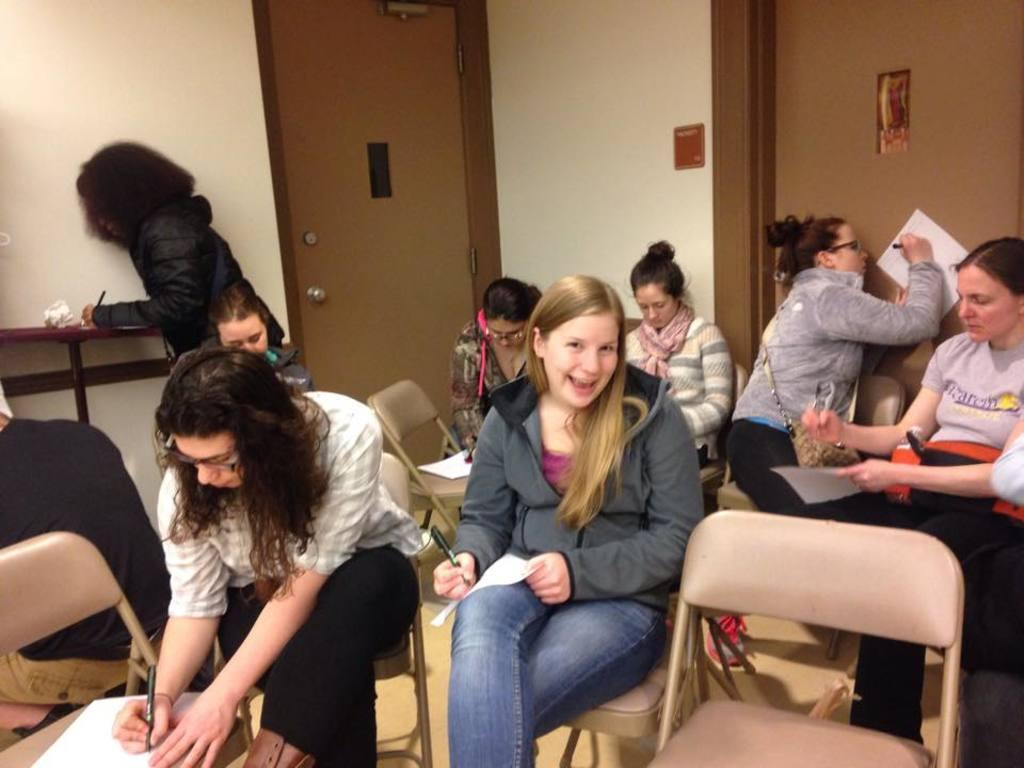What type of furniture is present in the room? There are chairs in the room. What are the girls doing while sitting on the chairs? The girls are writing on paper with pens. How many doors are in the room? There are two doors in the room, located on adjacent sides. Did the earthquake cause the girls to drop their pens in the image? There is no mention of an earthquake in the image, and the girls are not shown dropping their pens. What time of day is it in the image? The time of day is not mentioned in the image, so it cannot be determined. 